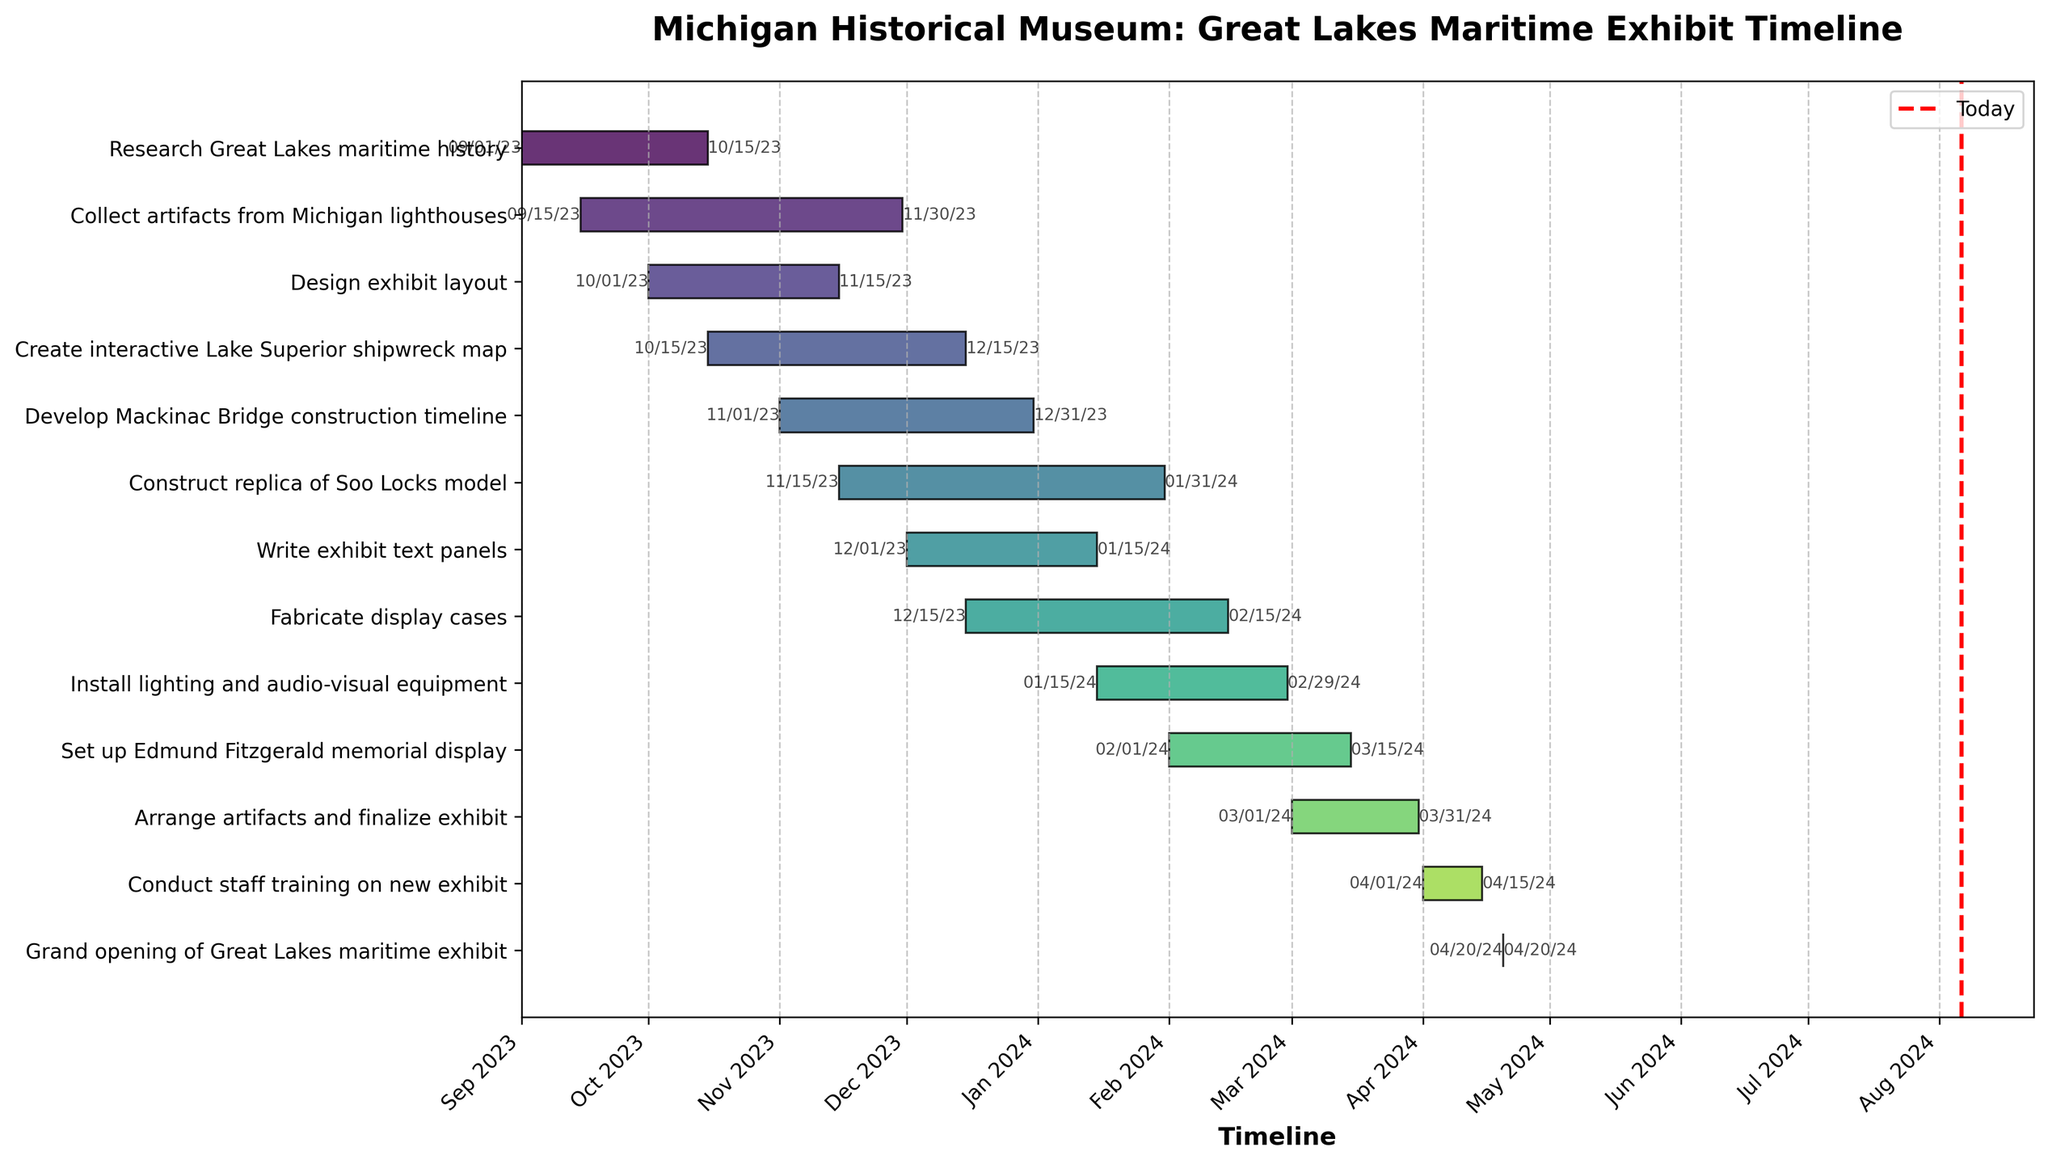How long is "Research Great Lakes maritime history" planned to take? Look at the start date (2023-09-01) and the end date (2023-10-15). Find the difference in days. The task starts on September 1st and ends on October 15th. That duration is approximately 45 days.
Answer: 45 days What is the title of the Gantt Chart? The title is usually prominently displayed at the top of the chart. It indicates the main subject or purpose of the chart.
Answer: Michigan Historical Museum: Great Lakes Maritime Exhibit Timeline Which task starts the earliest? Check the start dates for all tasks listed on the chart. The task with the earliest start date is "Research Great Lakes maritime history," starting on 2023-09-01.
Answer: Research Great Lakes maritime history Which tasks are scheduled to end in December 2023? Look at the end dates for all tasks. The tasks ending in December 2023 are "Create interactive Lake Superior shipwreck map" (2023-12-15) and "Develop Mackinac Bridge construction timeline" (2023-12-31).
Answer: Create interactive Lake Superior shipwreck map, Develop Mackinac Bridge construction timeline Which task has the longest duration? Calculate the duration for each task by finding the difference between the end date and start date. The longest duration is for "Construct replica of Soo Locks model," from 2023-11-15 to 2024-01-31, lasting about 77 days.
Answer: Construct replica of Soo Locks model How many days after "Write exhibit text panels" starts does "Install lighting and audio-visual equipment" start? "Write exhibit text panels" starts on 2023-12-01, and "Install lighting and audio-visual equipment" starts on 2024-01-15. Calculate the difference in days between the two start dates. The difference is approximately 45 days.
Answer: 45 days Which tasks overlap with "Design exhibit layout"? "Design exhibit layout" runs from 2023-10-01 to 2023-11-15. Check other tasks that have start and end dates within this period. The overlapping tasks are "Collect artifacts from Michigan lighthouses" and "Create interactive Lake Superior shipwreck map."
Answer: Collect artifacts from Michigan lighthouses, Create interactive Lake Superior shipwreck map What is the total number of tasks planned for the exhibit? Count the number of distinct tasks listed in the Gantt Chart. There are 12 tasks listed.
Answer: 12 tasks When does the last task end before the grand opening? Identify the tasks and their end dates, and find the task with the latest end date before the grand opening. The task "Conduct staff training on new exhibit" ends on 2024-04-15, shortly before the grand opening on 2024-04-20.
Answer: 2024-04-15 Which task starts immediately after "Install lighting and audio-visual equipment"? "Install lighting and audio-visual equipment" ends on 2024-02-29. The task starting immediately after that is "Set up Edmund Fitzgerald memorial display," which begins on 2024-02-01. The next one after it is "Arrange artifacts and finalize exhibit," which starts on 2024-03-01.
Answer: Arrange artifacts and finalize exhibit 